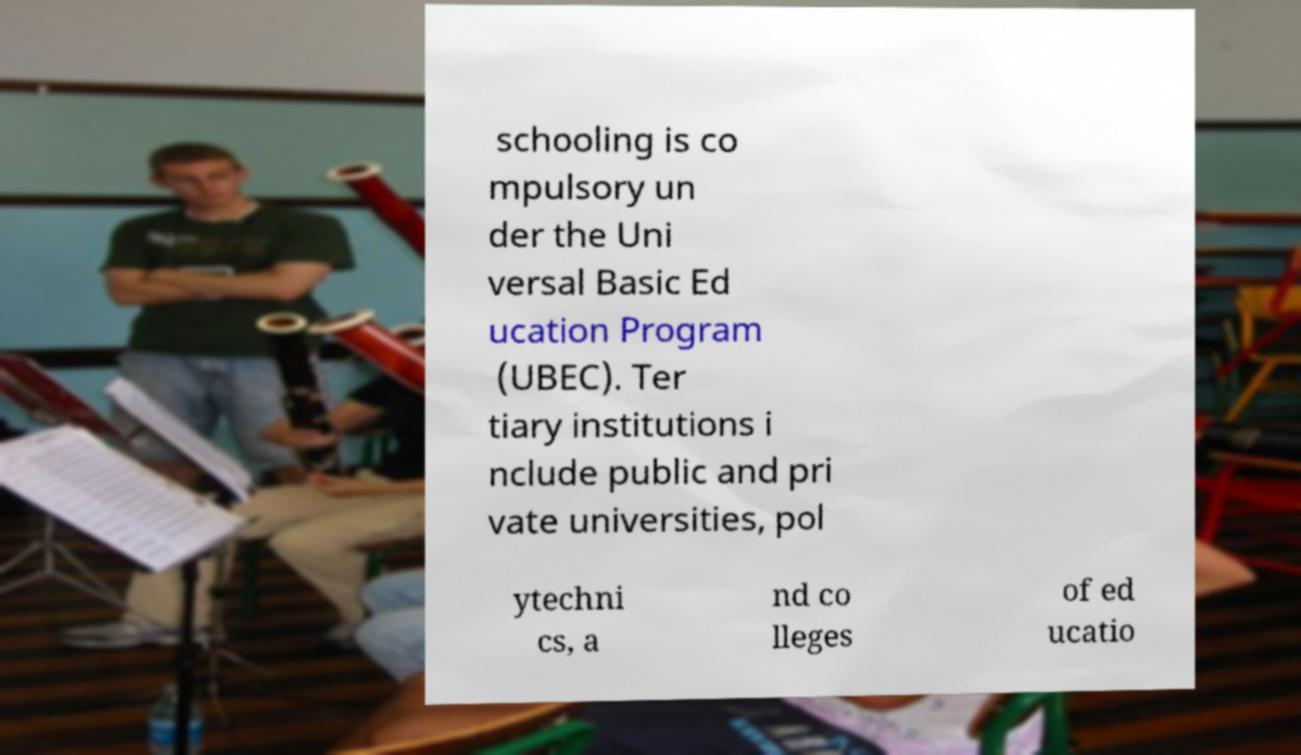I need the written content from this picture converted into text. Can you do that? schooling is co mpulsory un der the Uni versal Basic Ed ucation Program (UBEC). Ter tiary institutions i nclude public and pri vate universities, pol ytechni cs, a nd co lleges of ed ucatio 